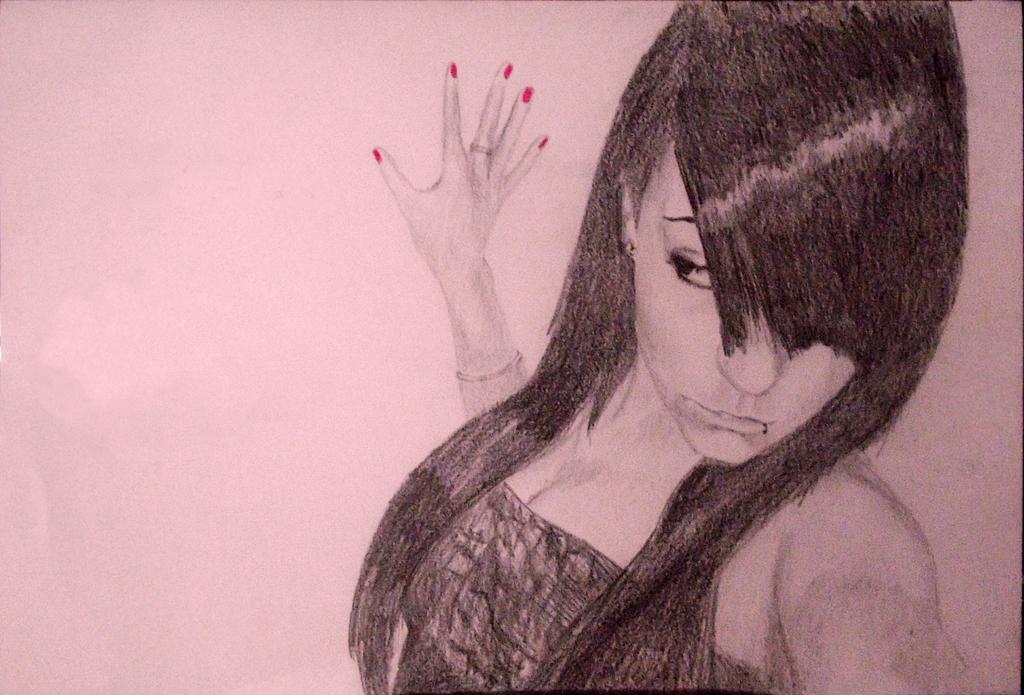Please provide a concise description of this image. In this image, we can see a woman sketch on the white surface. 